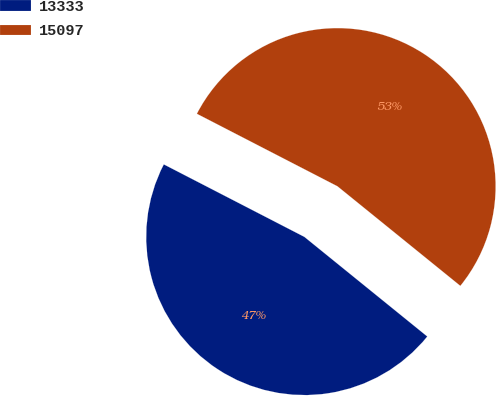<chart> <loc_0><loc_0><loc_500><loc_500><pie_chart><fcel>13333<fcel>15097<nl><fcel>46.74%<fcel>53.26%<nl></chart> 